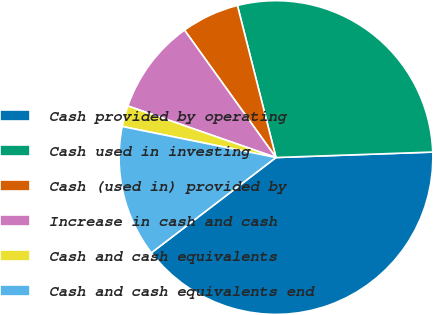Convert chart to OTSL. <chart><loc_0><loc_0><loc_500><loc_500><pie_chart><fcel>Cash provided by operating<fcel>Cash used in investing<fcel>Cash (used in) provided by<fcel>Increase in cash and cash<fcel>Cash and cash equivalents<fcel>Cash and cash equivalents end<nl><fcel>40.17%<fcel>28.4%<fcel>5.96%<fcel>9.76%<fcel>2.16%<fcel>13.56%<nl></chart> 